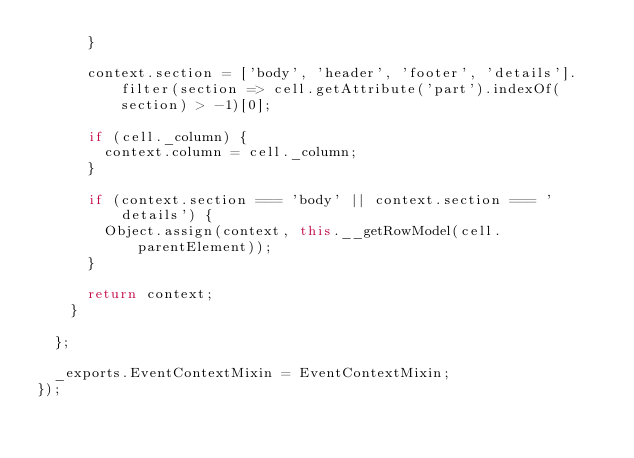<code> <loc_0><loc_0><loc_500><loc_500><_JavaScript_>      }

      context.section = ['body', 'header', 'footer', 'details'].filter(section => cell.getAttribute('part').indexOf(section) > -1)[0];

      if (cell._column) {
        context.column = cell._column;
      }

      if (context.section === 'body' || context.section === 'details') {
        Object.assign(context, this.__getRowModel(cell.parentElement));
      }

      return context;
    }

  };

  _exports.EventContextMixin = EventContextMixin;
});</code> 